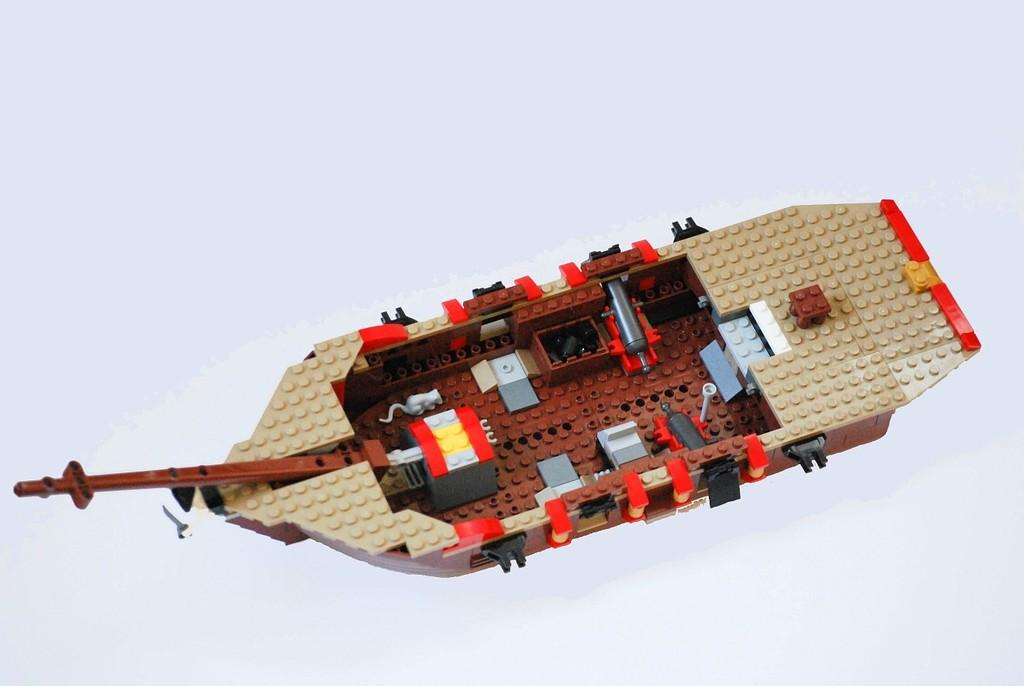What is the main subject of the image? The main subject of the image is a boat made up of miniature. What can be seen in the background of the image? The background of the image is white. What type of bell is ringing in the image? There is no bell present in the image. What force is being applied to the boat in the image? There is no force being applied to the boat in the image; it is stationary. 